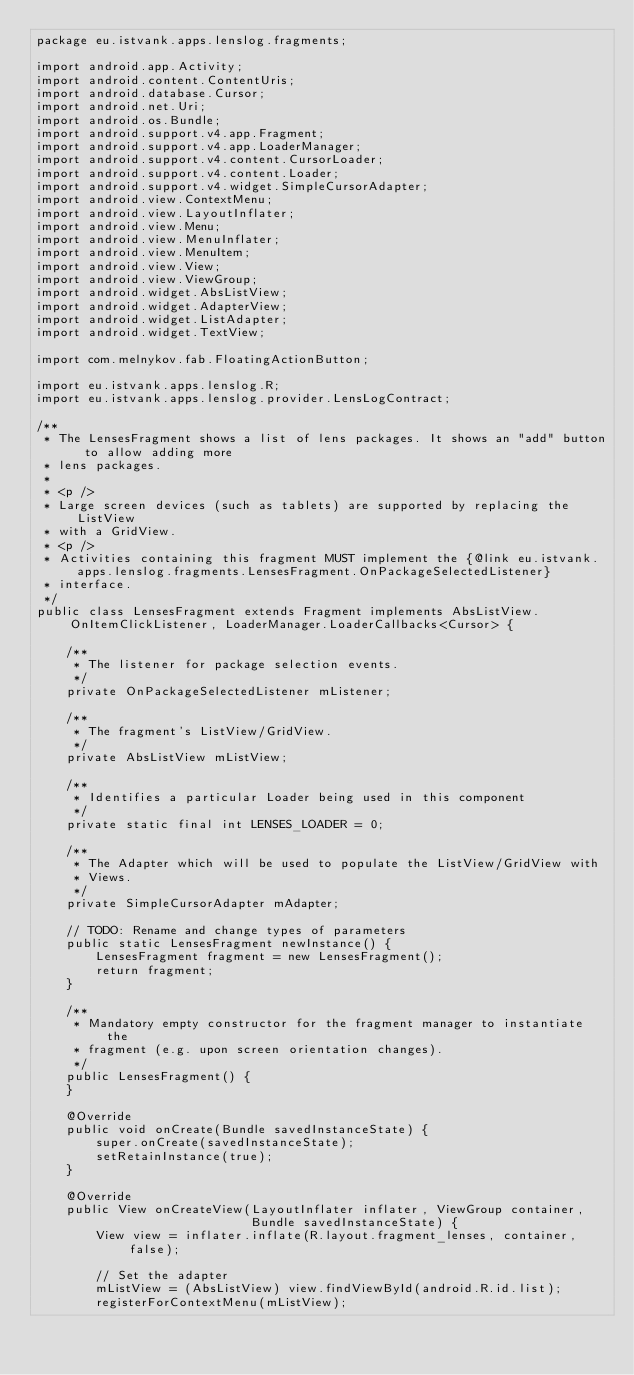Convert code to text. <code><loc_0><loc_0><loc_500><loc_500><_Java_>package eu.istvank.apps.lenslog.fragments;

import android.app.Activity;
import android.content.ContentUris;
import android.database.Cursor;
import android.net.Uri;
import android.os.Bundle;
import android.support.v4.app.Fragment;
import android.support.v4.app.LoaderManager;
import android.support.v4.content.CursorLoader;
import android.support.v4.content.Loader;
import android.support.v4.widget.SimpleCursorAdapter;
import android.view.ContextMenu;
import android.view.LayoutInflater;
import android.view.Menu;
import android.view.MenuInflater;
import android.view.MenuItem;
import android.view.View;
import android.view.ViewGroup;
import android.widget.AbsListView;
import android.widget.AdapterView;
import android.widget.ListAdapter;
import android.widget.TextView;

import com.melnykov.fab.FloatingActionButton;

import eu.istvank.apps.lenslog.R;
import eu.istvank.apps.lenslog.provider.LensLogContract;

/**
 * The LensesFragment shows a list of lens packages. It shows an "add" button to allow adding more
 * lens packages.
 *
 * <p />
 * Large screen devices (such as tablets) are supported by replacing the ListView
 * with a GridView.
 * <p />
 * Activities containing this fragment MUST implement the {@link eu.istvank.apps.lenslog.fragments.LensesFragment.OnPackageSelectedListener}
 * interface.
 */
public class LensesFragment extends Fragment implements AbsListView.OnItemClickListener, LoaderManager.LoaderCallbacks<Cursor> {

    /**
     * The listener for package selection events.
     */
    private OnPackageSelectedListener mListener;

    /**
     * The fragment's ListView/GridView.
     */
    private AbsListView mListView;

    /**
     * Identifies a particular Loader being used in this component
     */
    private static final int LENSES_LOADER = 0;

    /**
     * The Adapter which will be used to populate the ListView/GridView with
     * Views.
     */
    private SimpleCursorAdapter mAdapter;

    // TODO: Rename and change types of parameters
    public static LensesFragment newInstance() {
        LensesFragment fragment = new LensesFragment();
        return fragment;
    }

    /**
     * Mandatory empty constructor for the fragment manager to instantiate the
     * fragment (e.g. upon screen orientation changes).
     */
    public LensesFragment() {
    }

    @Override
    public void onCreate(Bundle savedInstanceState) {
        super.onCreate(savedInstanceState);
        setRetainInstance(true);
    }

    @Override
    public View onCreateView(LayoutInflater inflater, ViewGroup container,
                             Bundle savedInstanceState) {
        View view = inflater.inflate(R.layout.fragment_lenses, container, false);

        // Set the adapter
        mListView = (AbsListView) view.findViewById(android.R.id.list);
        registerForContextMenu(mListView);
</code> 